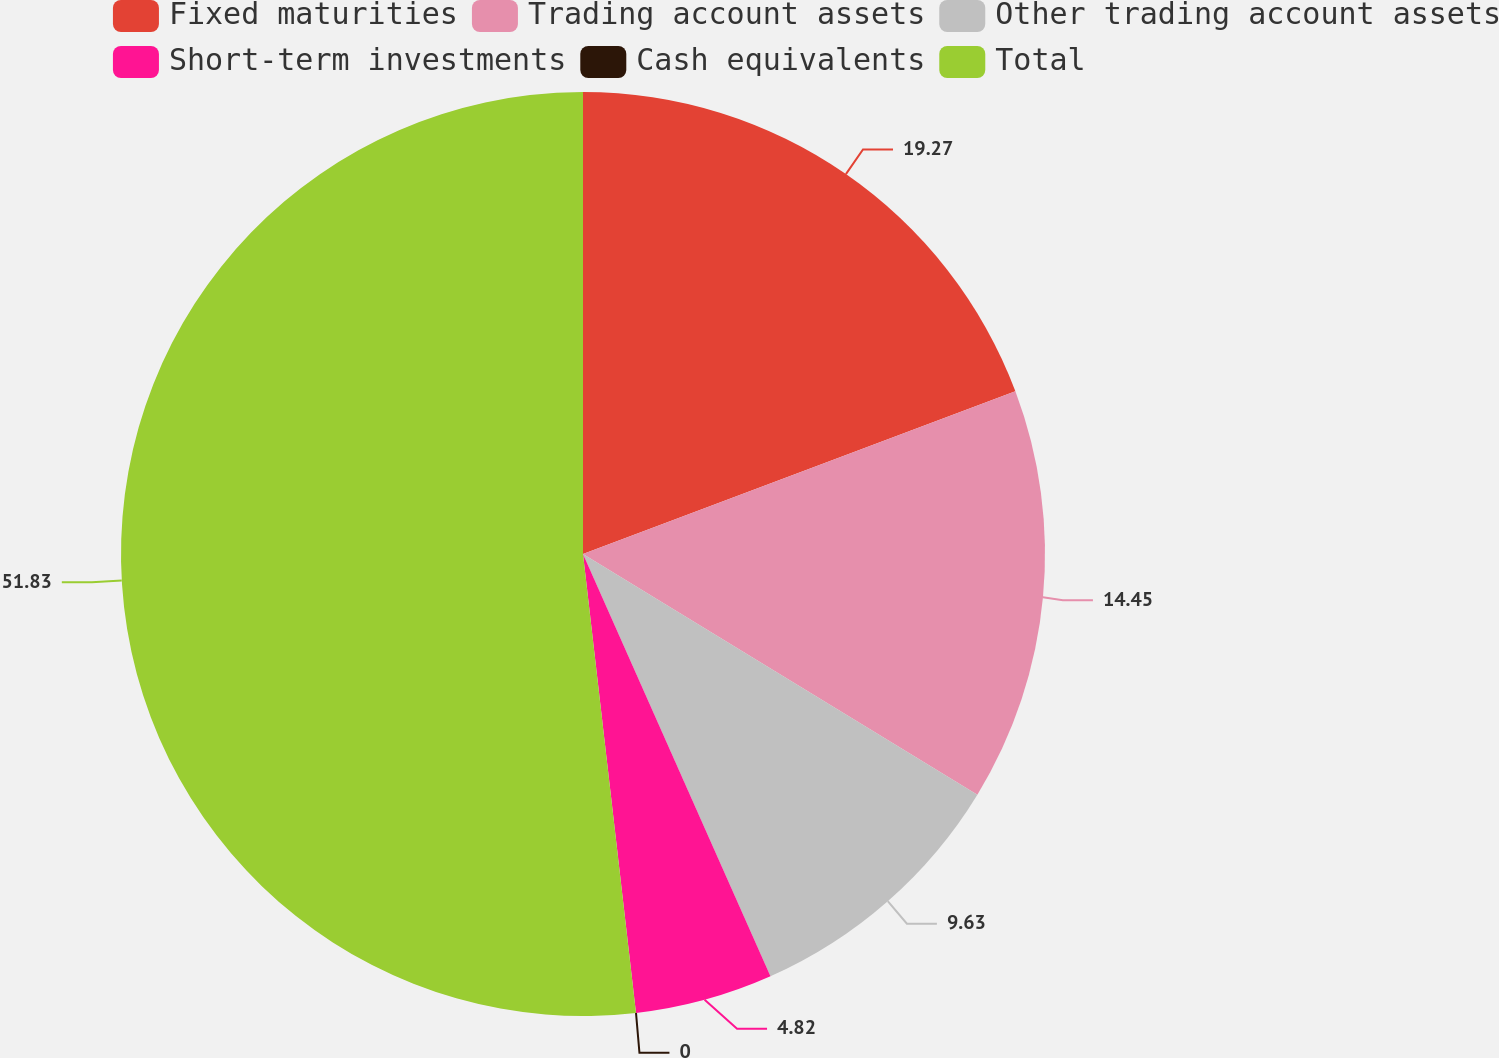Convert chart. <chart><loc_0><loc_0><loc_500><loc_500><pie_chart><fcel>Fixed maturities<fcel>Trading account assets<fcel>Other trading account assets<fcel>Short-term investments<fcel>Cash equivalents<fcel>Total<nl><fcel>19.27%<fcel>14.45%<fcel>9.63%<fcel>4.82%<fcel>0.0%<fcel>51.83%<nl></chart> 